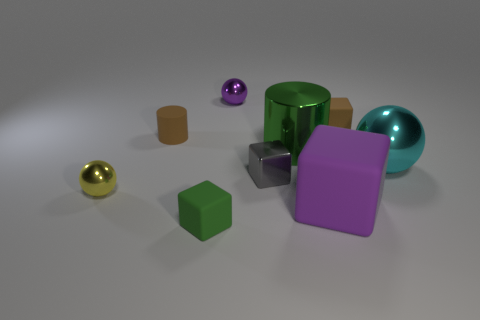There is a brown object right of the tiny rubber block that is to the left of the big purple matte block to the left of the large sphere; how big is it?
Your answer should be compact. Small. Are there fewer metallic balls than yellow spheres?
Give a very brief answer. No. What is the color of the other small object that is the same shape as the yellow thing?
Your answer should be compact. Purple. Are there any purple shiny spheres on the right side of the shiny thing on the right side of the rubber cube that is behind the yellow thing?
Keep it short and to the point. No. Is the purple metal thing the same shape as the cyan metallic thing?
Keep it short and to the point. Yes. Is the number of tiny gray blocks behind the large ball less than the number of blue cubes?
Offer a very short reply. No. What is the color of the cube in front of the purple thing to the right of the cylinder to the right of the gray block?
Ensure brevity in your answer.  Green. What number of rubber objects are tiny gray blocks or purple objects?
Your answer should be very brief. 1. Is the yellow shiny object the same size as the purple block?
Your response must be concise. No. Are there fewer rubber things behind the tiny rubber cylinder than large green objects that are in front of the tiny purple metallic thing?
Your response must be concise. No. 